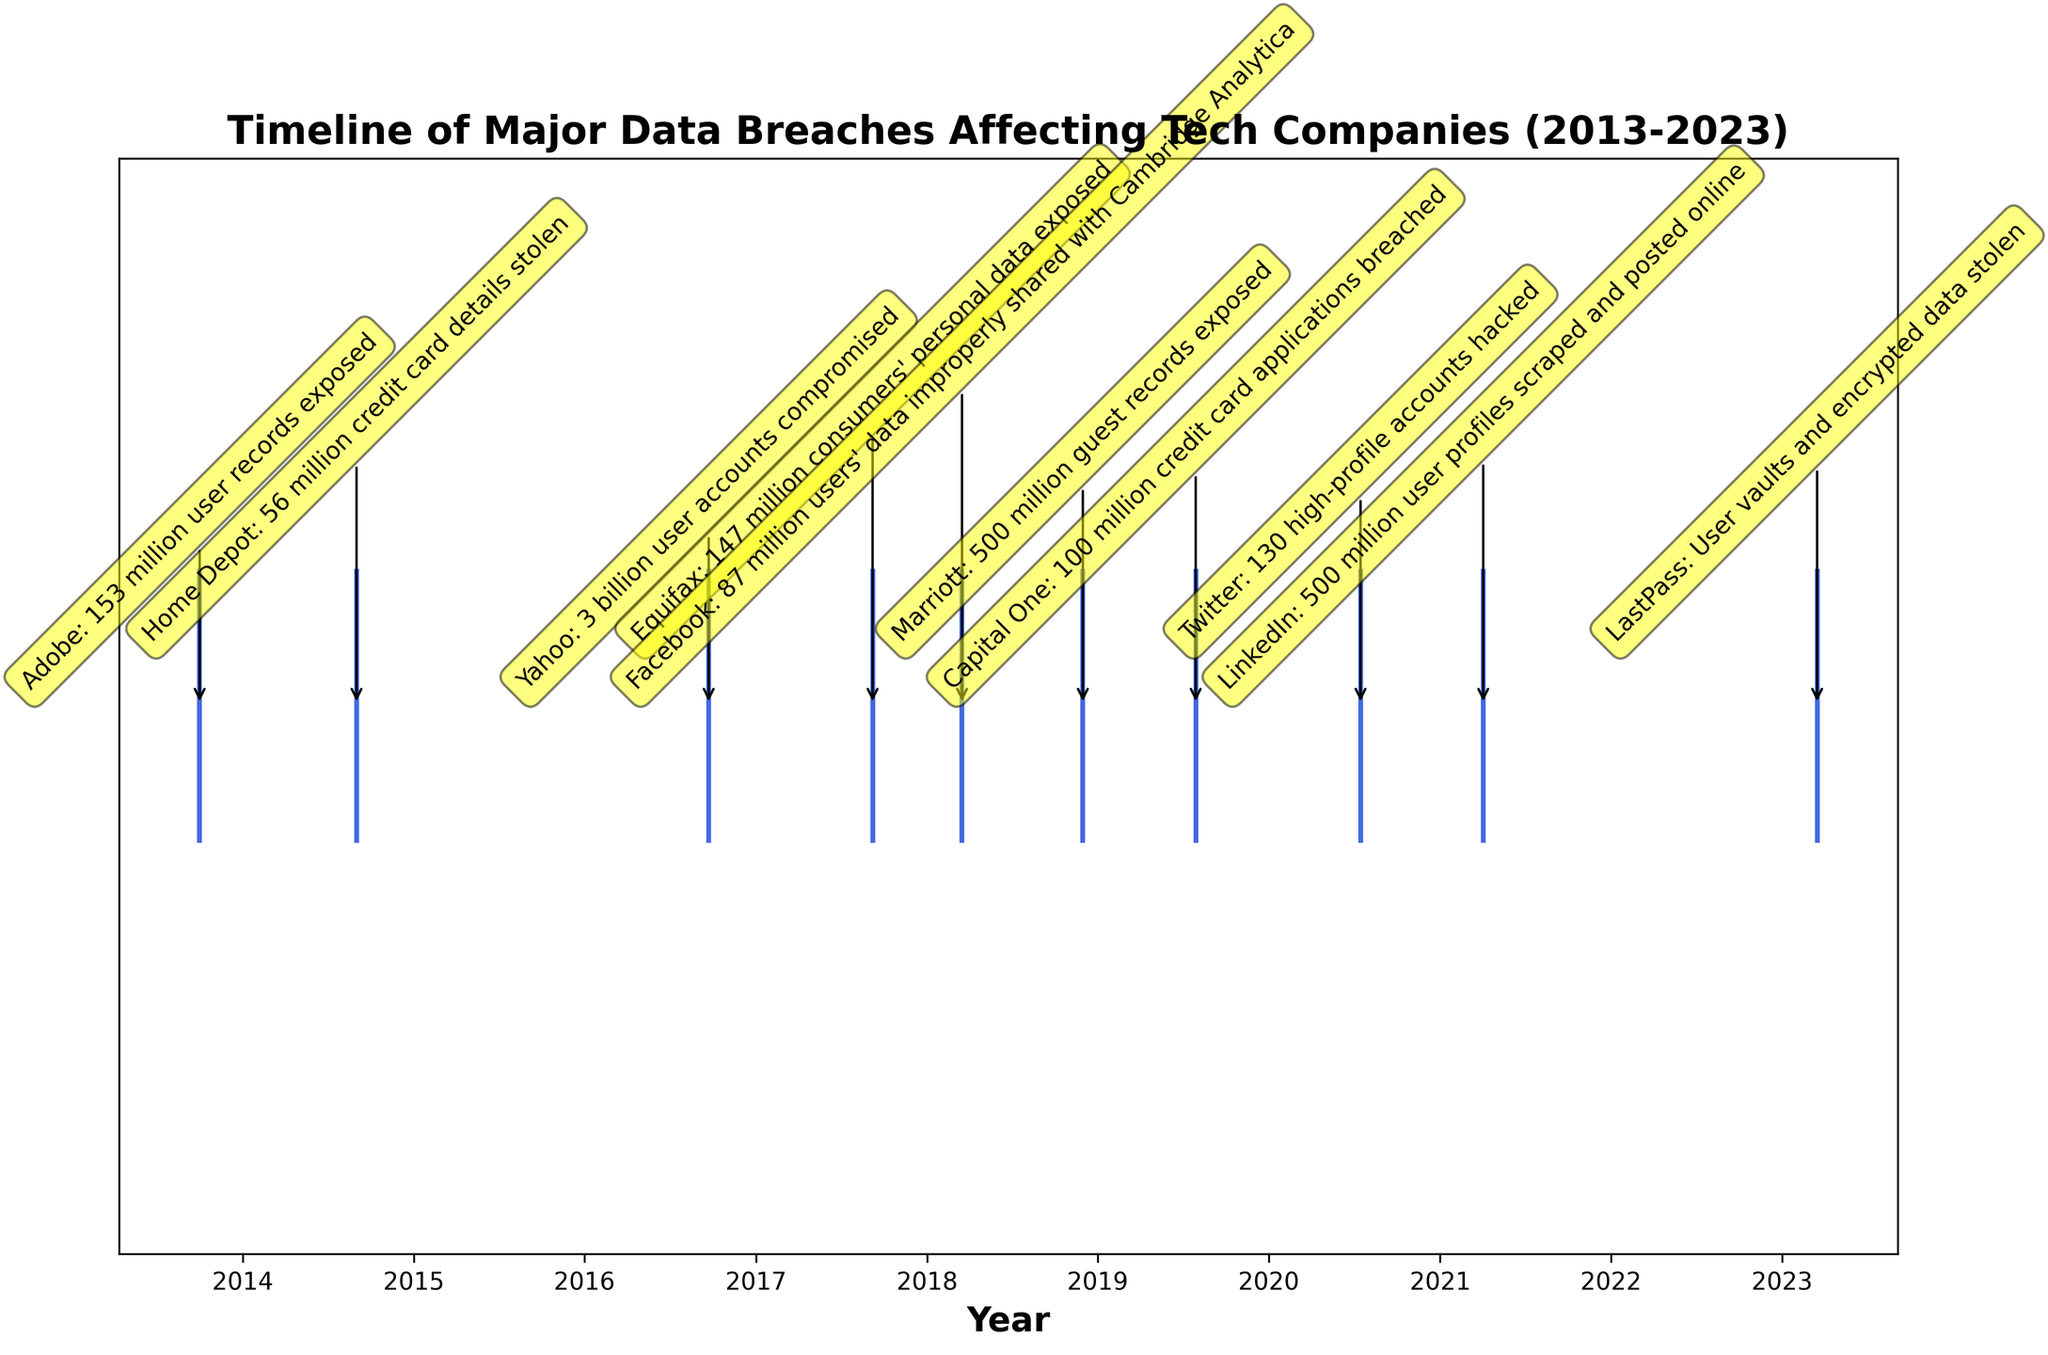What is the title of the plot? The title is located at the top of the figure. It provides an overview of what the timeline is about. The title reads "Timeline of Major Data Breaches Affecting Tech Companies (2013-2023)".
Answer: Timeline of Major Data Breaches Affecting Tech Companies (2013-2023) How many major data breaches are displayed in the timeline? You can count the number of events plotted along the timeline to determine how many data breaches are shown.
Answer: 10 Which company experienced a data breach in 2016? Find the year 2016 on the x-axis and locate the event closest to that year. The annotation will provide the company name. According to the figure, Yahoo experienced a data breach in 2016.
Answer: Yahoo What is the time span of the data breaches shown in the plot? The earliest and latest dates on the timeline indicate the time span. The earliest is in 2013 and the latest is in 2023.
Answer: 10 years Which year had the most data breaches according to the figure? Observe the timeline and see which year has the highest number of events. The year 2018 has two breaches, which is the most in a single year.
Answer: 2018 How many years since the most recent data breach shown on the plot? Identify the most recent date on the timeline and subtract it from the current year, 2023. The most recent data breach on the plot is in 2023 itself.
Answer: 0 years Which company had a breach affecting the largest number of user accounts? Review the descriptions of the data breaches to find the one mentioning the largest number of user accounts. Yahoo's breach in 2016 compromised 3 billion user accounts, which is the highest.
Answer: Yahoo Which event occurred closest to the middle of the timeline? The midpoint of the timeline is around 2018. Looking at the data points around this year, Marriott's data breach occurred in November 2018, which is closest to the middle of the timeline.
Answer: Marriott Compare the number of breaches before and after 2017. Which period had more breaches? Count the number of breaches that occurred before 2017 and after 2017. Before 2017, there were 3 breaches (Adobe, Home Depot, and Yahoo). After 2017, there were 6 breaches (Equifax, Facebook, Marriott, Capital One, Twitter, LinkedIn, LastPass). Thus, more breaches occurred after 2017.
Answer: After 2017 What was the nature of the data stolen in the 2020 Twitter breach? Examine the annotation for the 2020 Twitter breach to understand what was compromised. The annotation indicates that 130 high-profile accounts were hacked.
Answer: 130 high-profile accounts hacked 